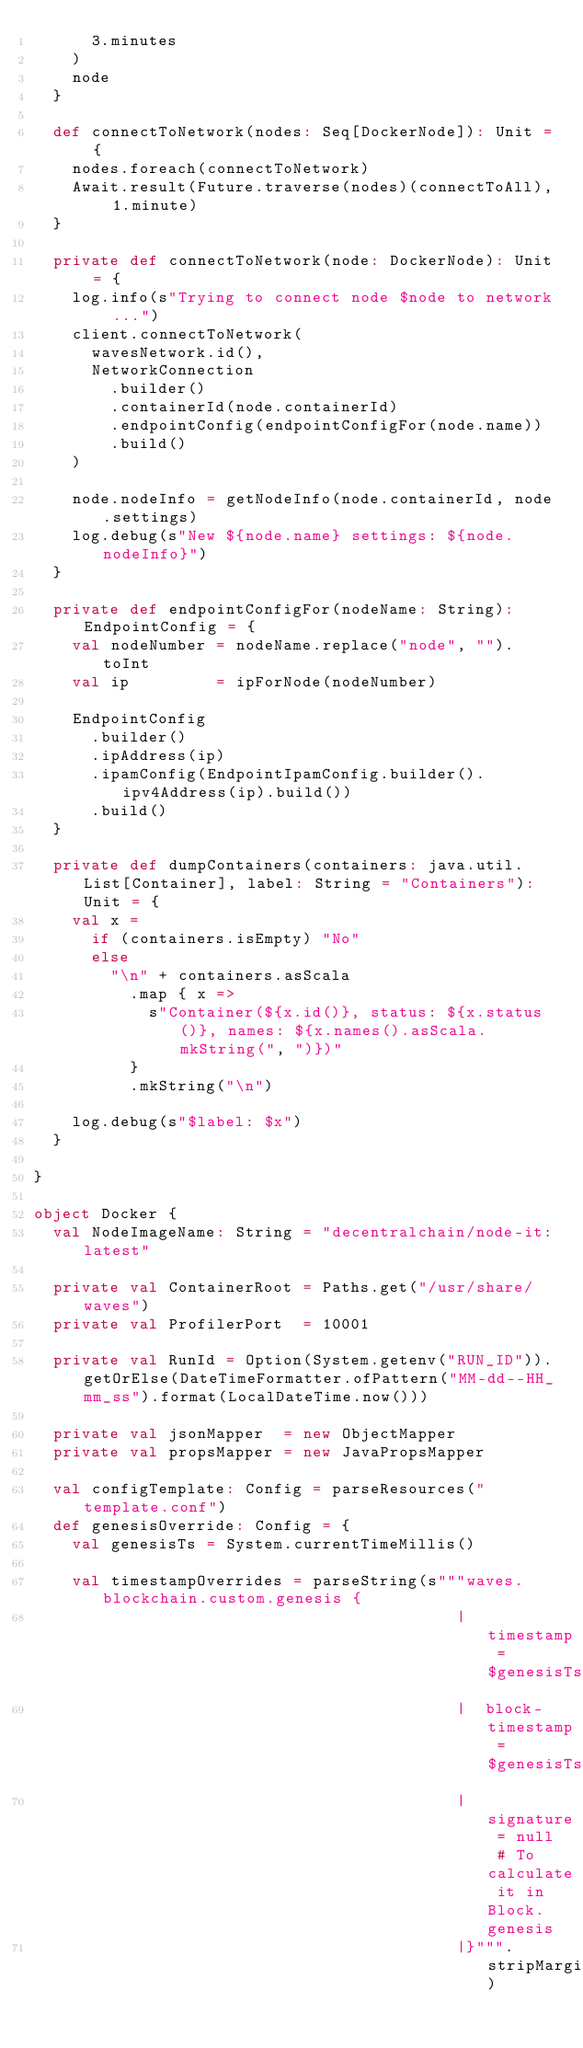<code> <loc_0><loc_0><loc_500><loc_500><_Scala_>      3.minutes
    )
    node
  }

  def connectToNetwork(nodes: Seq[DockerNode]): Unit = {
    nodes.foreach(connectToNetwork)
    Await.result(Future.traverse(nodes)(connectToAll), 1.minute)
  }

  private def connectToNetwork(node: DockerNode): Unit = {
    log.info(s"Trying to connect node $node to network ...")
    client.connectToNetwork(
      wavesNetwork.id(),
      NetworkConnection
        .builder()
        .containerId(node.containerId)
        .endpointConfig(endpointConfigFor(node.name))
        .build()
    )

    node.nodeInfo = getNodeInfo(node.containerId, node.settings)
    log.debug(s"New ${node.name} settings: ${node.nodeInfo}")
  }

  private def endpointConfigFor(nodeName: String): EndpointConfig = {
    val nodeNumber = nodeName.replace("node", "").toInt
    val ip         = ipForNode(nodeNumber)

    EndpointConfig
      .builder()
      .ipAddress(ip)
      .ipamConfig(EndpointIpamConfig.builder().ipv4Address(ip).build())
      .build()
  }

  private def dumpContainers(containers: java.util.List[Container], label: String = "Containers"): Unit = {
    val x =
      if (containers.isEmpty) "No"
      else
        "\n" + containers.asScala
          .map { x =>
            s"Container(${x.id()}, status: ${x.status()}, names: ${x.names().asScala.mkString(", ")})"
          }
          .mkString("\n")

    log.debug(s"$label: $x")
  }

}

object Docker {
  val NodeImageName: String = "decentralchain/node-it:latest"

  private val ContainerRoot = Paths.get("/usr/share/waves")
  private val ProfilerPort  = 10001

  private val RunId = Option(System.getenv("RUN_ID")).getOrElse(DateTimeFormatter.ofPattern("MM-dd--HH_mm_ss").format(LocalDateTime.now()))

  private val jsonMapper  = new ObjectMapper
  private val propsMapper = new JavaPropsMapper

  val configTemplate: Config = parseResources("template.conf")
  def genesisOverride: Config = {
    val genesisTs = System.currentTimeMillis()

    val timestampOverrides = parseString(s"""waves.blockchain.custom.genesis {
                                            |  timestamp = $genesisTs
                                            |  block-timestamp = $genesisTs
                                            |  signature = null # To calculate it in Block.genesis
                                            |}""".stripMargin)
</code> 